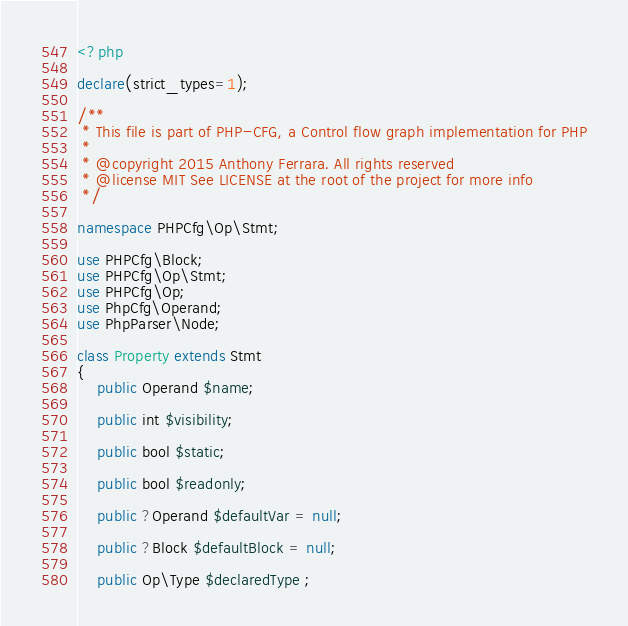Convert code to text. <code><loc_0><loc_0><loc_500><loc_500><_PHP_><?php

declare(strict_types=1);

/**
 * This file is part of PHP-CFG, a Control flow graph implementation for PHP
 *
 * @copyright 2015 Anthony Ferrara. All rights reserved
 * @license MIT See LICENSE at the root of the project for more info
 */

namespace PHPCfg\Op\Stmt;

use PHPCfg\Block;
use PHPCfg\Op\Stmt;
use PHPCfg\Op;
use PhpCfg\Operand;
use PhpParser\Node;

class Property extends Stmt
{
    public Operand $name;

    public int $visibility;

    public bool $static;

    public bool $readonly;

    public ?Operand $defaultVar = null;

    public ?Block $defaultBlock = null;

    public Op\Type $declaredType ;
</code> 